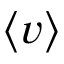<formula> <loc_0><loc_0><loc_500><loc_500>\langle v \rangle</formula> 